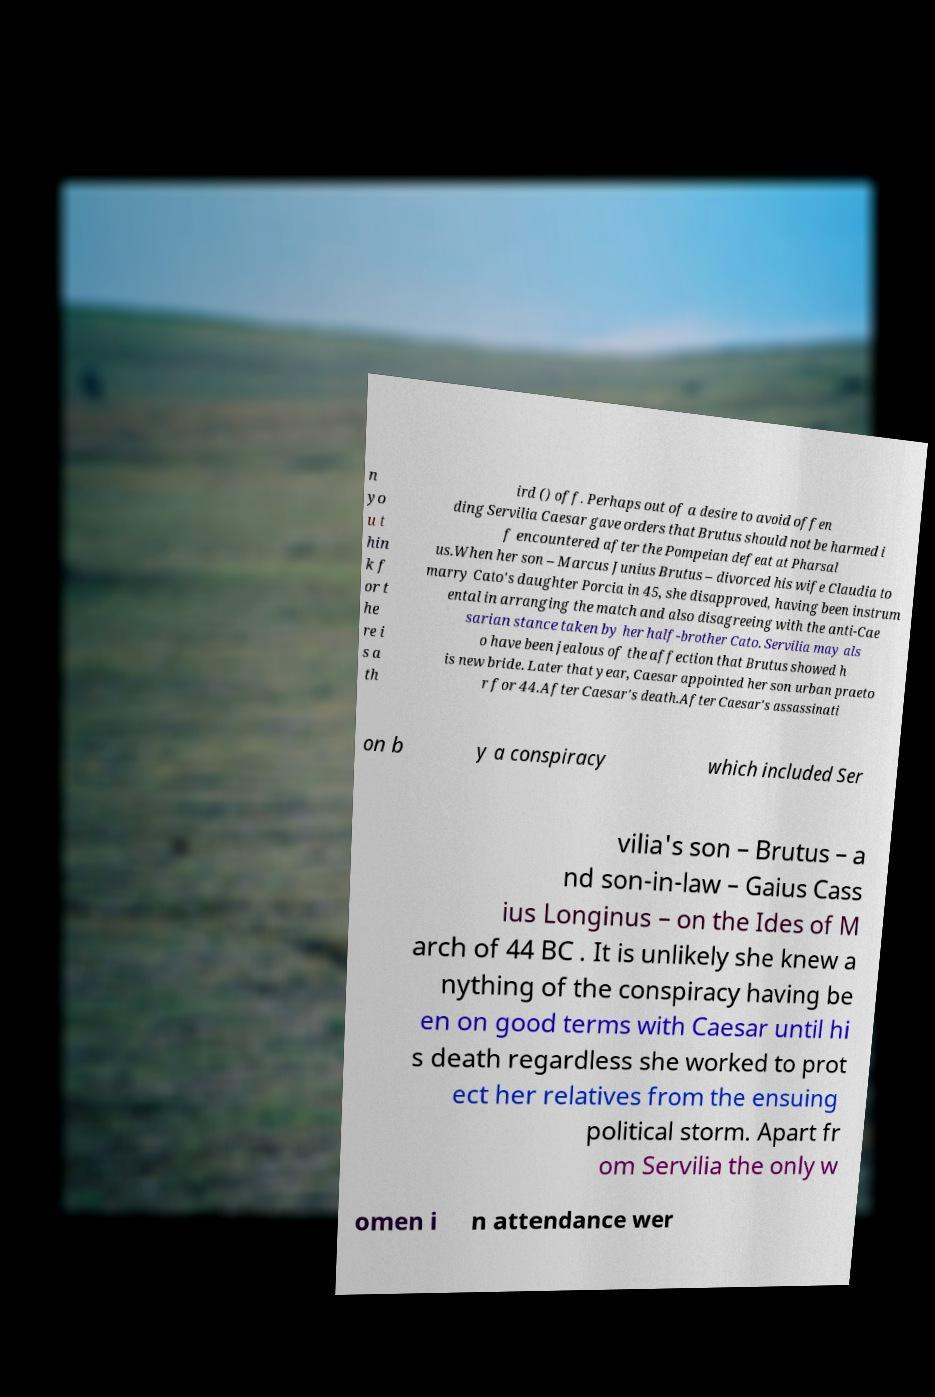Can you read and provide the text displayed in the image?This photo seems to have some interesting text. Can you extract and type it out for me? n yo u t hin k f or t he re i s a th ird () off. Perhaps out of a desire to avoid offen ding Servilia Caesar gave orders that Brutus should not be harmed i f encountered after the Pompeian defeat at Pharsal us.When her son – Marcus Junius Brutus – divorced his wife Claudia to marry Cato's daughter Porcia in 45, she disapproved, having been instrum ental in arranging the match and also disagreeing with the anti-Cae sarian stance taken by her half-brother Cato. Servilia may als o have been jealous of the affection that Brutus showed h is new bride. Later that year, Caesar appointed her son urban praeto r for 44.After Caesar's death.After Caesar's assassinati on b y a conspiracy which included Ser vilia's son – Brutus – a nd son-in-law – Gaius Cass ius Longinus – on the Ides of M arch of 44 BC . It is unlikely she knew a nything of the conspiracy having be en on good terms with Caesar until hi s death regardless she worked to prot ect her relatives from the ensuing political storm. Apart fr om Servilia the only w omen i n attendance wer 